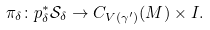Convert formula to latex. <formula><loc_0><loc_0><loc_500><loc_500>\pi _ { \delta } \colon p _ { \delta } ^ { * } { \mathcal { S _ { \delta } } } \rightarrow C _ { V ( \gamma ^ { \prime } ) } ( M ) \times I .</formula> 